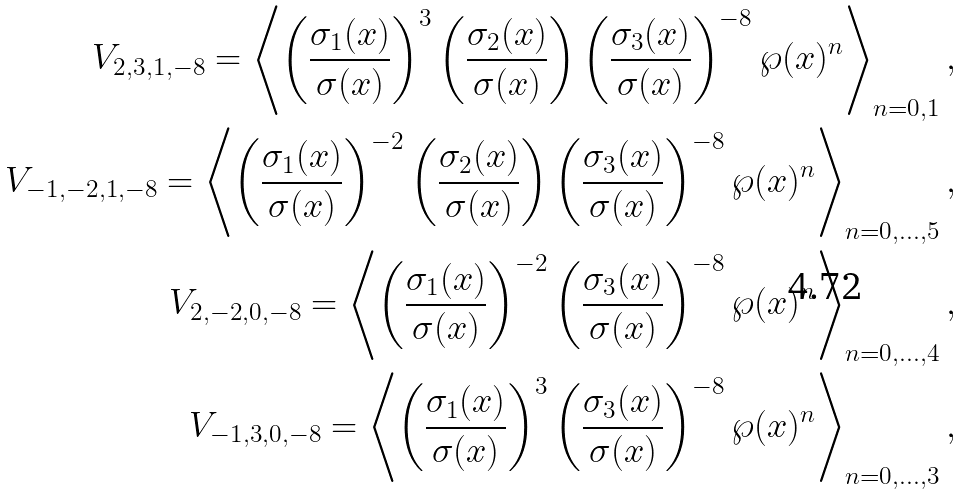Convert formula to latex. <formula><loc_0><loc_0><loc_500><loc_500>V _ { 2 , 3 , 1 , - 8 } = \left \langle \left ( \frac { \sigma _ { 1 } ( x ) } { \sigma ( x ) } \right ) ^ { 3 } \left ( \frac { \sigma _ { 2 } ( x ) } { \sigma ( x ) } \right ) \left ( \frac { \sigma _ { 3 } ( x ) } { \sigma ( x ) } \right ) ^ { - 8 } \wp ( x ) ^ { n } \right \rangle _ { n = 0 , 1 } , \\ V _ { - 1 , - 2 , 1 , - 8 } = \left \langle \left ( \frac { \sigma _ { 1 } ( x ) } { \sigma ( x ) } \right ) ^ { - 2 } \left ( \frac { \sigma _ { 2 } ( x ) } { \sigma ( x ) } \right ) \left ( \frac { \sigma _ { 3 } ( x ) } { \sigma ( x ) } \right ) ^ { - 8 } \wp ( x ) ^ { n } \right \rangle _ { n = 0 , \dots , 5 } , \\ V _ { 2 , - 2 , 0 , - 8 } = \left \langle \left ( \frac { \sigma _ { 1 } ( x ) } { \sigma ( x ) } \right ) ^ { - 2 } \left ( \frac { \sigma _ { 3 } ( x ) } { \sigma ( x ) } \right ) ^ { - 8 } \wp ( x ) ^ { n } \right \rangle _ { n = 0 , \dots , 4 } , \\ V _ { - 1 , 3 , 0 , - 8 } = \left \langle \left ( \frac { \sigma _ { 1 } ( x ) } { \sigma ( x ) } \right ) ^ { 3 } \left ( \frac { \sigma _ { 3 } ( x ) } { \sigma ( x ) } \right ) ^ { - 8 } \wp ( x ) ^ { n } \right \rangle _ { n = 0 , \dots , 3 } ,</formula> 